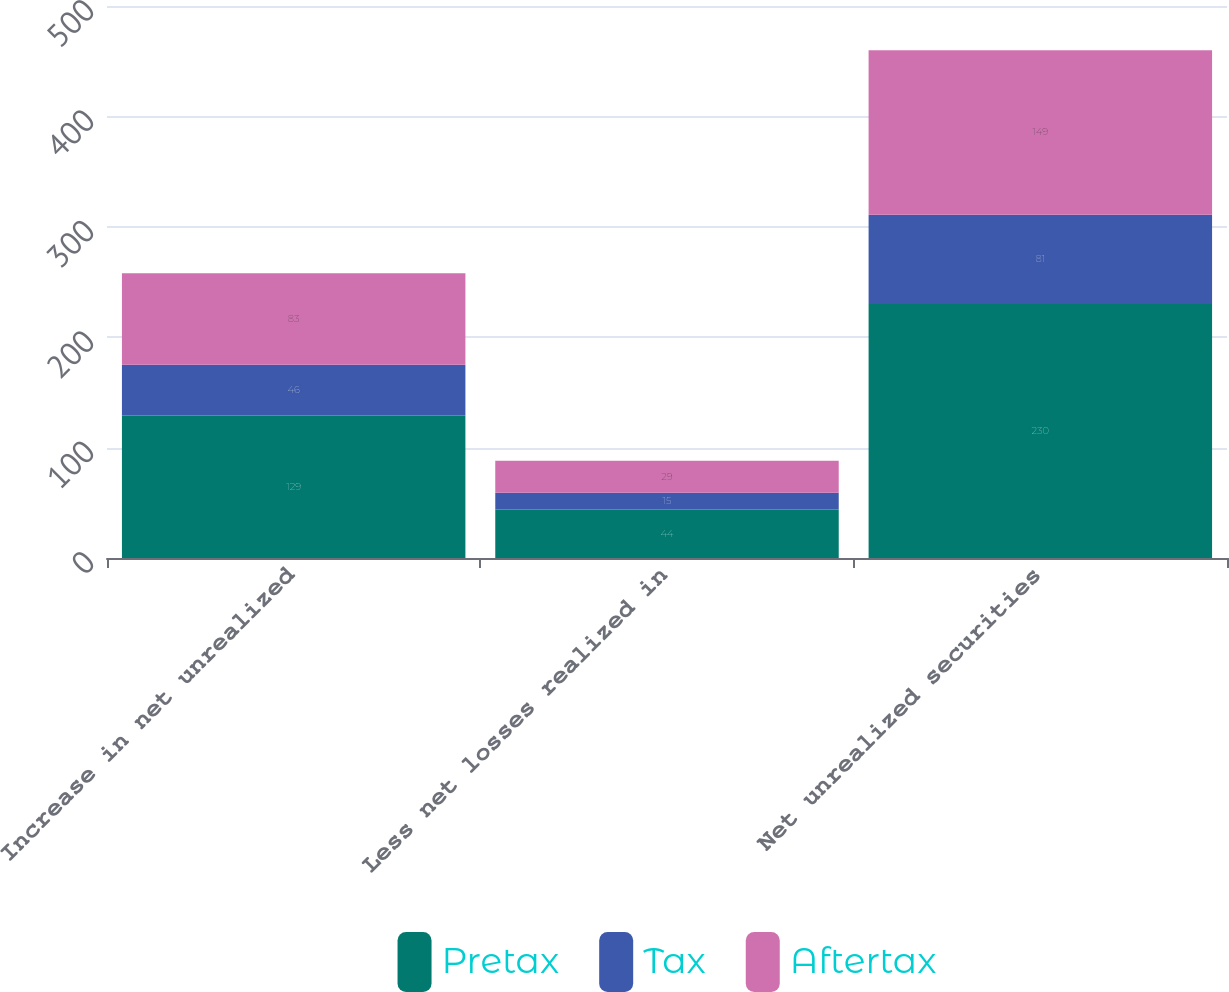Convert chart. <chart><loc_0><loc_0><loc_500><loc_500><stacked_bar_chart><ecel><fcel>Increase in net unrealized<fcel>Less net losses realized in<fcel>Net unrealized securities<nl><fcel>Pretax<fcel>129<fcel>44<fcel>230<nl><fcel>Tax<fcel>46<fcel>15<fcel>81<nl><fcel>Aftertax<fcel>83<fcel>29<fcel>149<nl></chart> 